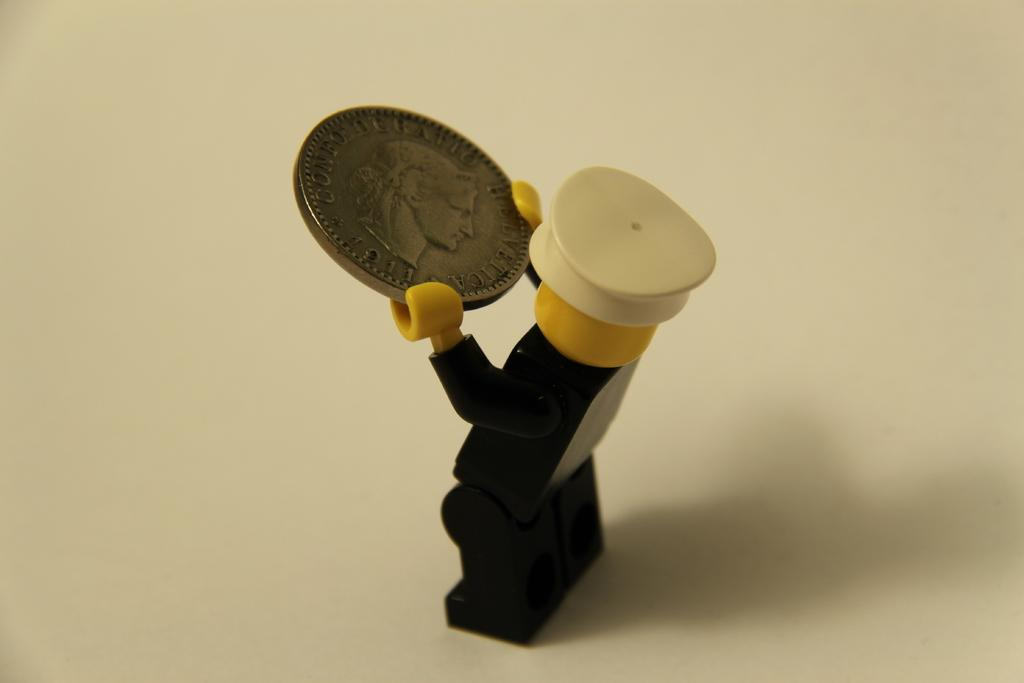What is the main subject of the image? The main subject of the image is a person holding a coin. What is the person doing with the coin? The person is holding the coin in the center of the image. What is the color of the surface at the bottom of the image? The surface at the bottom of the image is white. Is the person in the image smiling while driving a car? There is no indication of a person driving a car or smiling in the image. The image only shows a person holding a coin. 